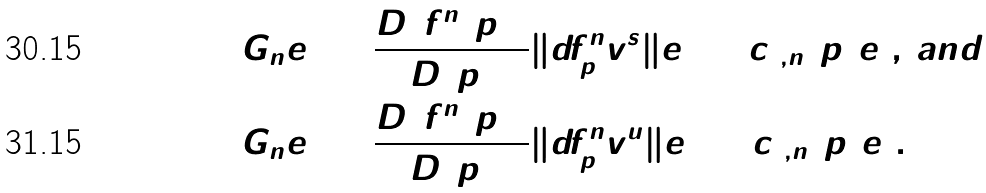Convert formula to latex. <formula><loc_0><loc_0><loc_500><loc_500>G _ { n } e _ { 1 } & = \frac { D ( f ^ { n } ( p ) ) } { D ( p ) } \| d f ^ { n } _ { p } v _ { 0 } ^ { s } \| e _ { 1 } = c _ { 1 , n } ( p ) e _ { 1 } , \, a n d \\ G _ { n } e _ { 2 } & = \frac { D ( f ^ { n } ( p ) ) } { D ( p ) } \| d f ^ { n } _ { p } v _ { 0 } ^ { u } \| e _ { 2 } = c _ { 2 , n } ( p ) e _ { 2 } .</formula> 